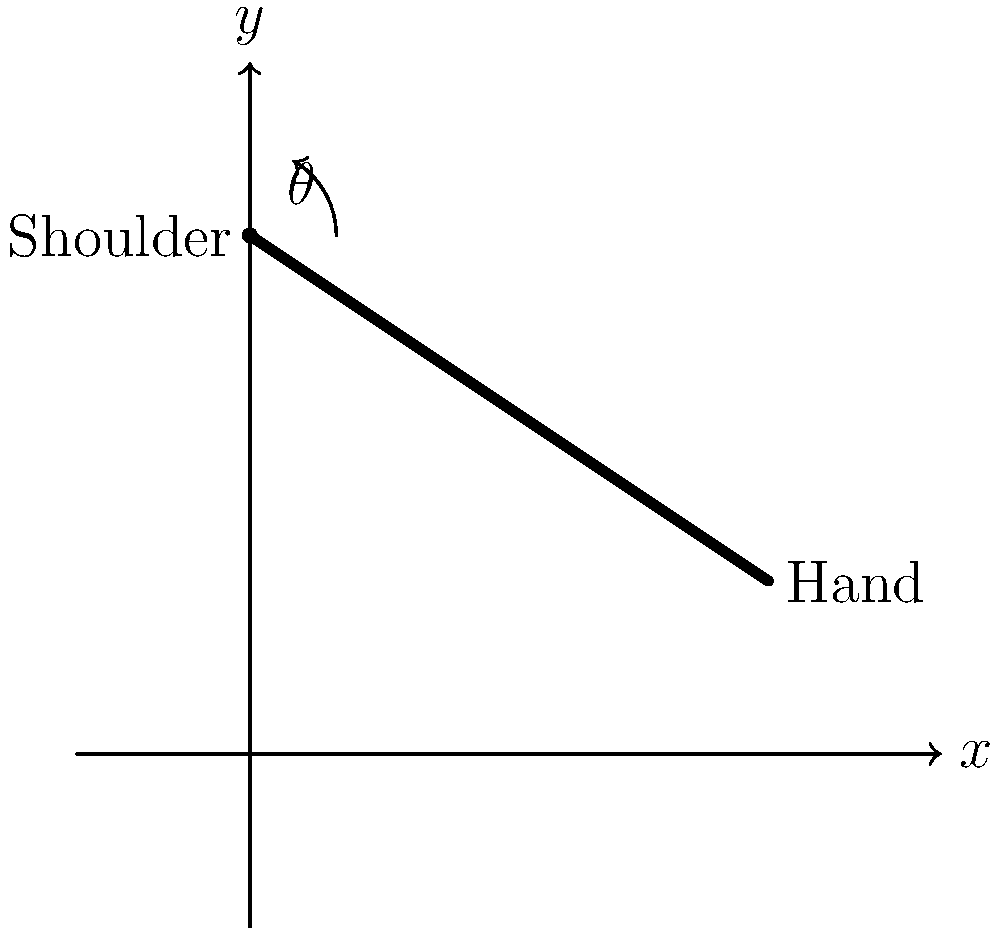A paper manufacturer needs to reach for high stacks of paper on a shelf. If the shoulder joint is at the origin (0,3) and the hand position is at (3,1), what is the angle $\theta$ (in degrees) between the arm and the horizontal axis? Assume the arm moves in a straight line from the shoulder to the hand. To find the angle $\theta$, we can use the inverse tangent (arctangent) function. Here's how:

1. Identify the coordinates:
   Shoulder: (0,3)
   Hand: (3,1)

2. Calculate the differences in x and y:
   $\Delta x = 3 - 0 = 3$
   $\Delta y = 1 - 3 = -2$

3. Calculate the angle using arctangent:
   $\theta = \arctan(\frac{-\Delta y}{\Delta x})$
   $\theta = \arctan(\frac{2}{3})$

4. Convert radians to degrees:
   $\theta = \arctan(\frac{2}{3}) \cdot \frac{180^{\circ}}{\pi}$

5. Calculate the final result:
   $\theta \approx 33.69^{\circ}$

The angle is measured from the positive x-axis (horizontal) to the arm, so this result is correct as is.
Answer: $33.69^{\circ}$ 